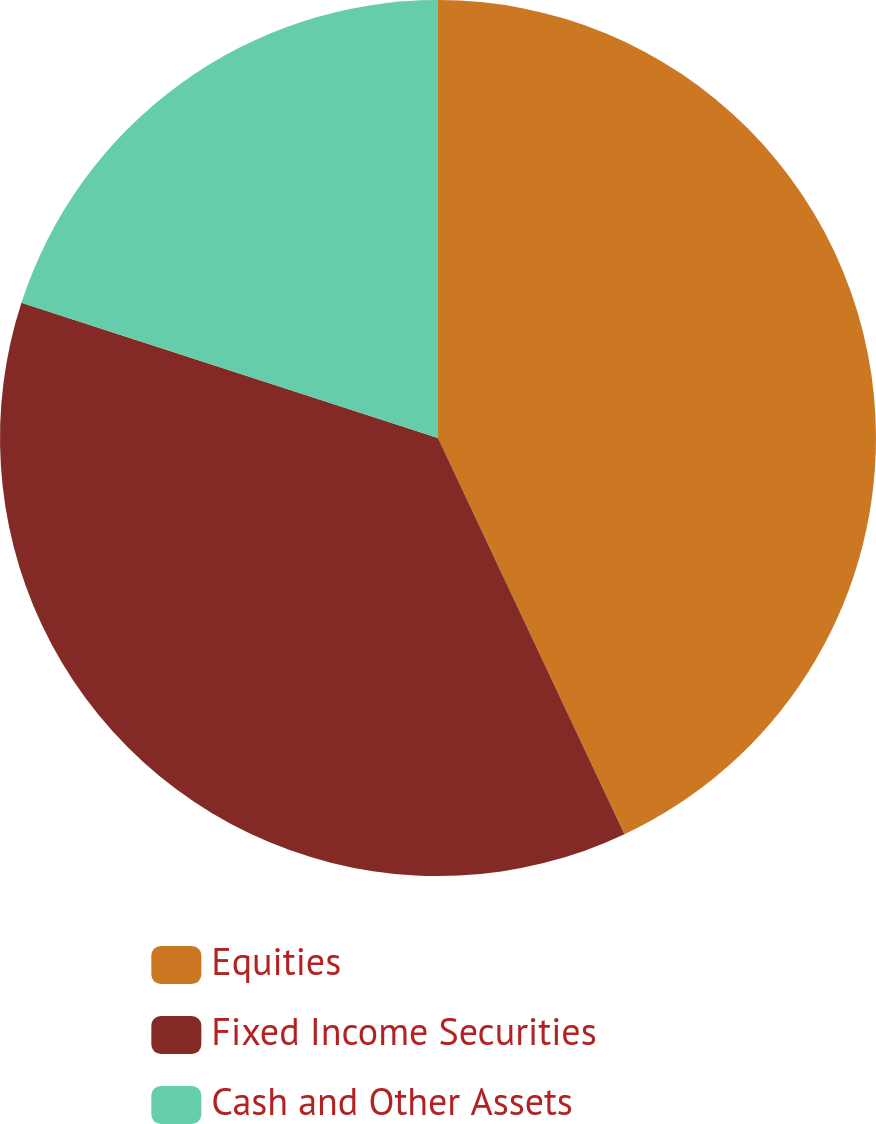<chart> <loc_0><loc_0><loc_500><loc_500><pie_chart><fcel>Equities<fcel>Fixed Income Securities<fcel>Cash and Other Assets<nl><fcel>43.0%<fcel>37.0%<fcel>20.0%<nl></chart> 